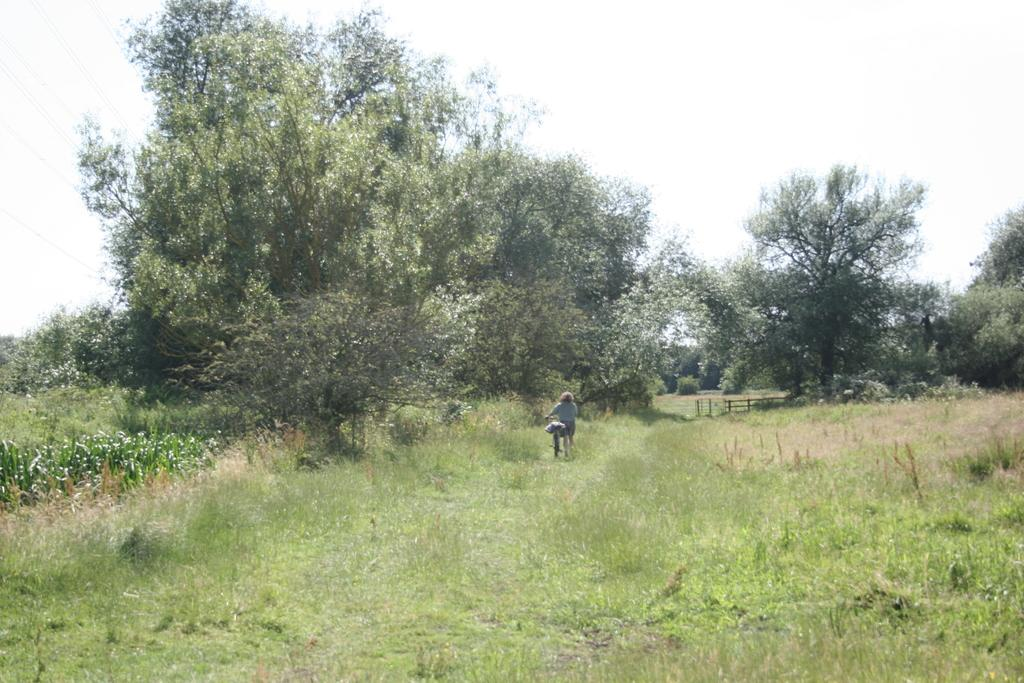Who is present in the image? There is a woman in the image. What is the woman holding in the image? The woman is holding a bicycle. Can you describe the bicycle in the image? There is an object on the bicycle. What type of terrain is visible in the image? Grass is visible on the ground. What can be seen in the background of the image? There are trees in the background of the image. What type of medical advice is the woman giving to the tree in the image? There is no tree present in the image, and the woman is not giving any medical advice. 